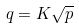<formula> <loc_0><loc_0><loc_500><loc_500>q = K \sqrt { p }</formula> 